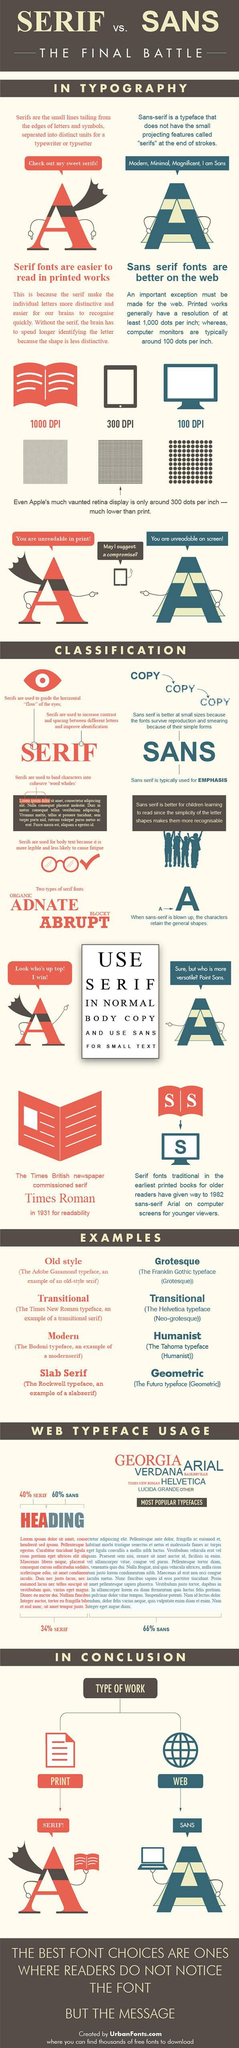What is the name of the serif font introduced in 1932?
Answer the question with a short phrase. times roman Based on this, how many dots are there in an inch, on a computer screen 100 dpi Which fonts are suited for the web? sans serif Which is the most populat sans font used in web? arial For body text on web which type of font is mostly used? sans serif Which type of fonts offer better readability in printed works? serif fonts Which is the second most popular sans font used in web? verdana For headings on web  which type of font is mostly used? sans serif Which font has simpler letter shpes? sans serif What is sans serif fonts reply to serif font, when the serif font says "you are unreadable in print"? you are unreadable on screen! Which is the most popular serif font used for web? georgia Grotesque is an example of serif or sans? sans Which fonts survive reproduction and smearing sans serif Based on this how many dots are there in an inch, in a printed medium? 1000 Which medium has the highest resolution? print In which type of font is the word "serif" written at the top? serif 